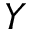<formula> <loc_0><loc_0><loc_500><loc_500>Y</formula> 